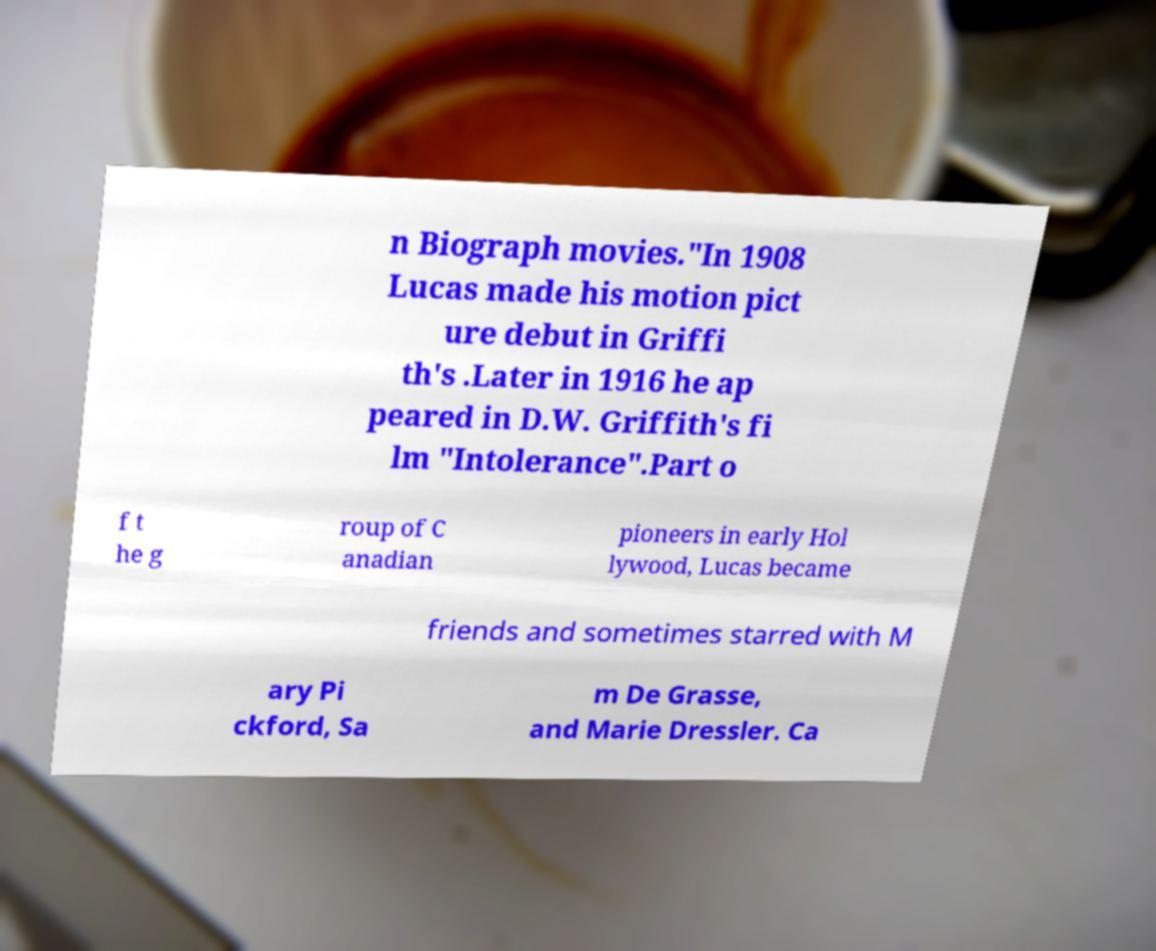Please identify and transcribe the text found in this image. n Biograph movies."In 1908 Lucas made his motion pict ure debut in Griffi th's .Later in 1916 he ap peared in D.W. Griffith's fi lm "Intolerance".Part o f t he g roup of C anadian pioneers in early Hol lywood, Lucas became friends and sometimes starred with M ary Pi ckford, Sa m De Grasse, and Marie Dressler. Ca 